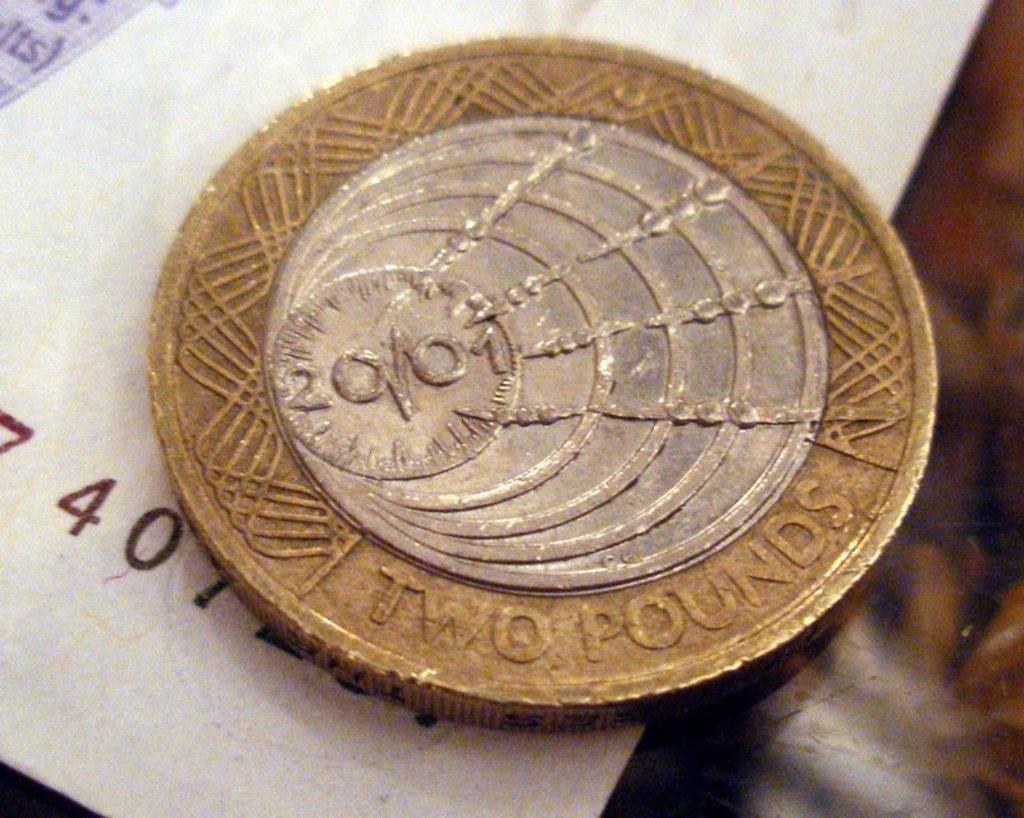How many pounds is the coin?
Offer a terse response. Two. 